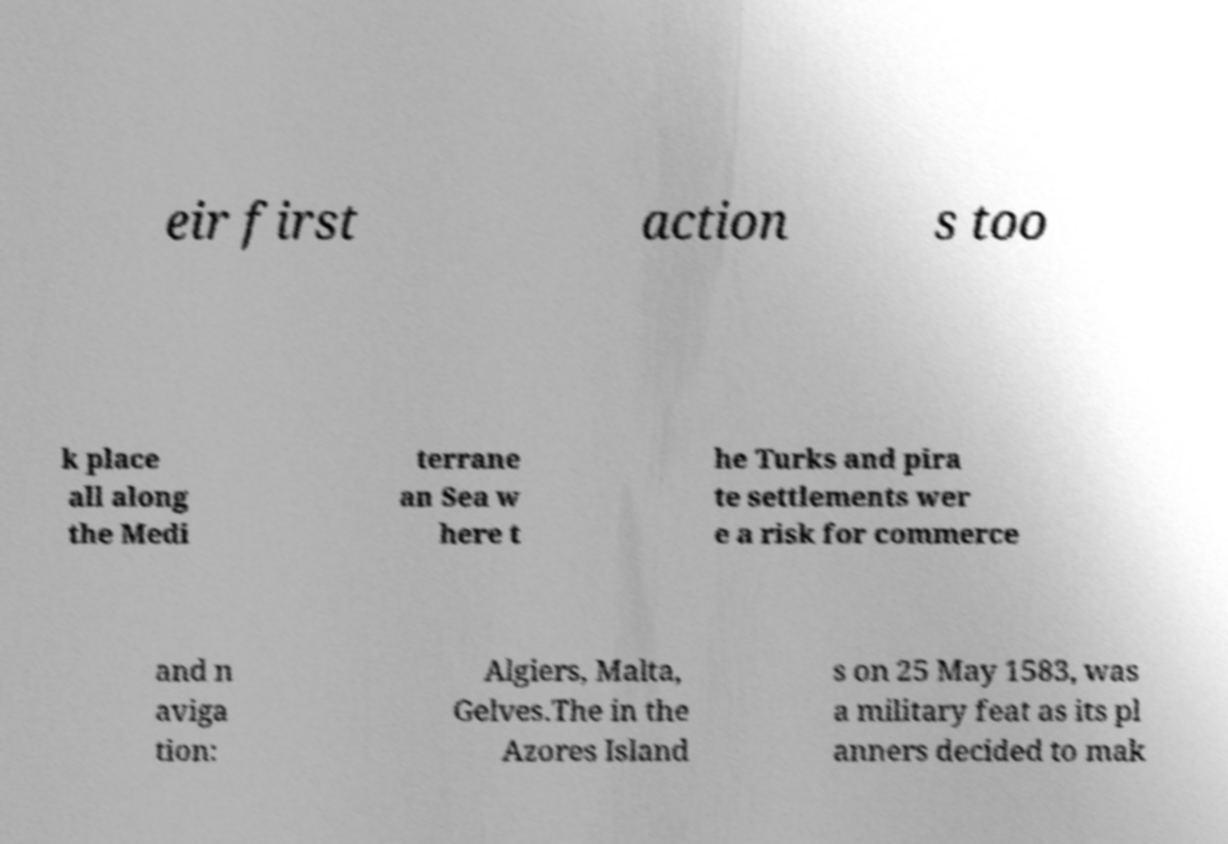What messages or text are displayed in this image? I need them in a readable, typed format. eir first action s too k place all along the Medi terrane an Sea w here t he Turks and pira te settlements wer e a risk for commerce and n aviga tion: Algiers, Malta, Gelves.The in the Azores Island s on 25 May 1583, was a military feat as its pl anners decided to mak 